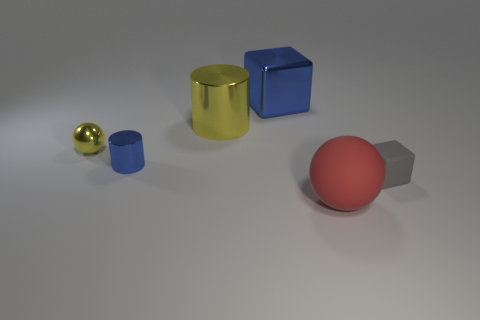How many objects are in the image? There are five objects in the image: a small golden sphere, a yellow cylinder, a small blue cylinder, a blue cube, and a red sphere with a matte finish. 